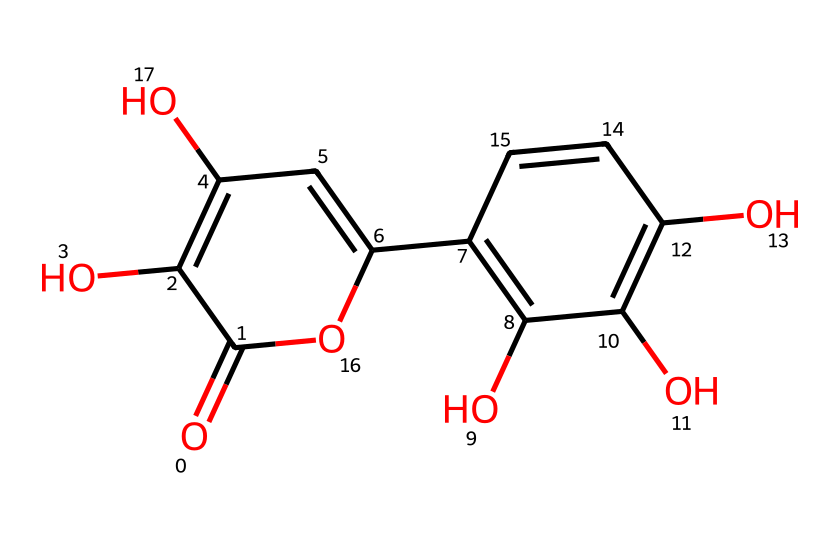How many hydroxyl groups are present in this molecule? By examining the SMILES representation, we can identify the hydroxyl groups (–OH). The structure includes several instances of ‘O’ directly bonded to carbon atoms, indicating hydroxyl groups. Counting these reveals that there are three such groups in the molecule.
Answer: three What is the molecular formula of quercetin? To derive the molecular formula, we need to tally the number of each atom type present in the structure based on the SMILES representation. There are 15 carbon atoms (C), 10 hydrogen atoms (H), and 7 oxygen atoms (O) in total, resulting in the formula C15H10O7.
Answer: C15H10O7 Which type of compound is quercetin classified as? Quercetin is classified as a flavonoid, which is a class of polyphenolic compounds known for their antioxidant properties. This classification is based on the chemical structure showcasing multiple aromatic rings and hydroxyl groups typical of flavonoids.
Answer: flavonoid How many rings are present in the quercetin structure? Examining the connectivity in the SMILES representation, we notice two distinct cyclic segments formed by carbon atoms linked to each other and characterized by double-bonds and hydroxyl groups. Counting these rings reveals that there are two rings in the quercetin structure.
Answer: two What is the significance of the presence of hydroxyl groups in quercetin? Hydroxyl groups play a critical role in influencing the antioxidant properties of quercetin. They enable hydrogen bonding and contribute to the molecule's ability to scavenge free radicals, thus enhancing its potential health benefits. This can be understood as the presence of multiple –OH groups in the structure acting as sites for these reactions.
Answer: antioxidant properties Which part of the structure indicates that quercetin can participate in hydrogen bonding? The hydroxyl (–OH) groups in the structure indicate potential sites for hydrogen bonding. In this molecule, the multiple –OH groups are the functional groups contributing to the capacity for hydrogen bonding due to their polarity and ability to act as hydrogen donors or acceptors. Therefore, the presence of these groups makes hydrogen bonding feasible.
Answer: hydroxyl groups 